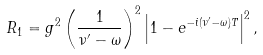<formula> <loc_0><loc_0><loc_500><loc_500>R _ { 1 } = g ^ { 2 } \left ( \frac { 1 } { \nu ^ { \prime } - \omega } \right ) ^ { 2 } \left | 1 - e ^ { - i ( \nu ^ { \prime } - \omega ) T } \right | ^ { 2 } ,</formula> 